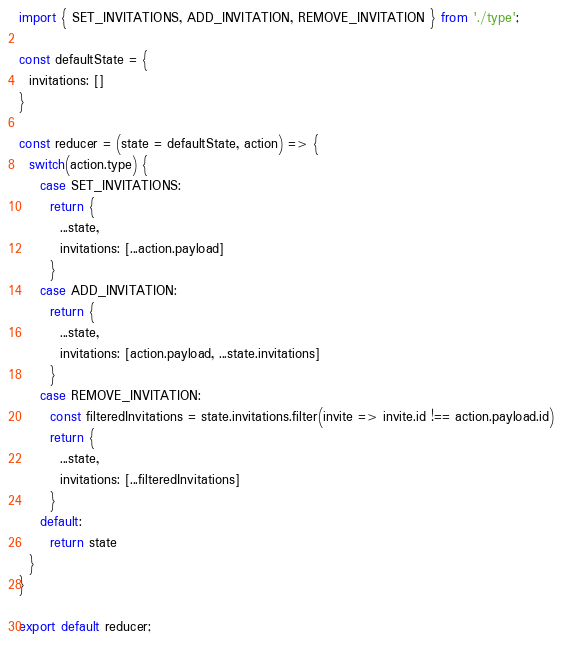Convert code to text. <code><loc_0><loc_0><loc_500><loc_500><_JavaScript_>import { SET_INVITATIONS, ADD_INVITATION, REMOVE_INVITATION } from './type';

const defaultState = {
  invitations: []
}

const reducer = (state = defaultState, action) => {
  switch(action.type) {
    case SET_INVITATIONS:
      return {
        ...state,
        invitations: [...action.payload]
      }
    case ADD_INVITATION:
      return {
        ...state,
        invitations: [action.payload, ...state.invitations]
      }
    case REMOVE_INVITATION:
      const filteredInvitations = state.invitations.filter(invite => invite.id !== action.payload.id)
      return {
        ...state,
        invitations: [...filteredInvitations]
      }
    default:
      return state
  }
}

export default reducer;</code> 